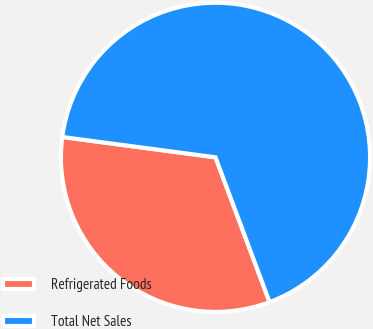Convert chart to OTSL. <chart><loc_0><loc_0><loc_500><loc_500><pie_chart><fcel>Refrigerated Foods<fcel>Total Net Sales<nl><fcel>32.79%<fcel>67.21%<nl></chart> 